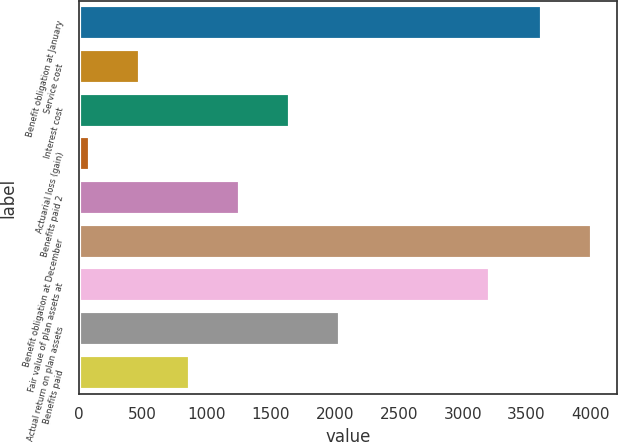Convert chart. <chart><loc_0><loc_0><loc_500><loc_500><bar_chart><fcel>Benefit obligation at January<fcel>Service cost<fcel>Interest cost<fcel>Actuarial loss (gain)<fcel>Benefits paid 2<fcel>Benefit obligation at December<fcel>Fair value of plan assets at<fcel>Actual return on plan assets<fcel>Benefits paid<nl><fcel>3618<fcel>479.7<fcel>1651.8<fcel>89<fcel>1261.1<fcel>4008.7<fcel>3214.6<fcel>2042.5<fcel>870.4<nl></chart> 